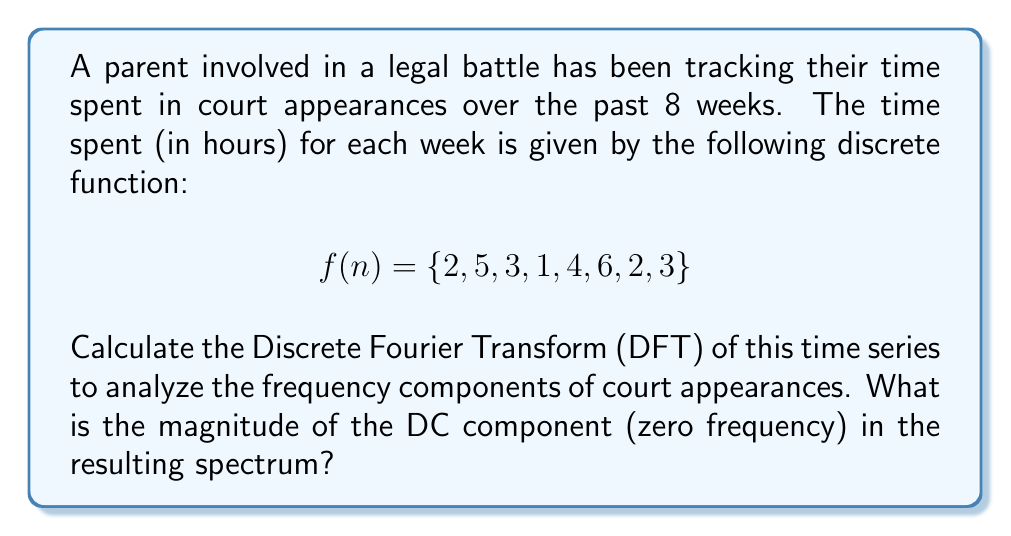Solve this math problem. To solve this problem, we need to apply the Discrete Fourier Transform (DFT) to the given time series and then find the magnitude of the DC component.

1. The DFT of a discrete signal $f(n)$ of length N is given by:

   $$F(k) = \sum_{n=0}^{N-1} f(n) e^{-i2\pi kn/N}$$

   where $k = 0, 1, ..., N-1$

2. In this case, $N = 8$ and $f(n) = \{2, 5, 3, 1, 4, 6, 2, 3\}$

3. The DC component corresponds to $k = 0$. Let's calculate $F(0)$:

   $$F(0) = \sum_{n=0}^{7} f(n) e^{-i2\pi (0)n/8} = \sum_{n=0}^{7} f(n)$$

4. Substituting the values:

   $$F(0) = 2 + 5 + 3 + 1 + 4 + 6 + 2 + 3 = 26$$

5. The magnitude of a complex number is given by its absolute value. Since $F(0)$ is real, its magnitude is simply its absolute value:

   $$|F(0)| = |26| = 26$$

6. Note that this result represents the sum of all time values in the original series, which makes sense for the DC component as it represents the average value of the signal multiplied by the number of samples.
Answer: The magnitude of the DC component in the spectrum is 26. 